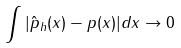Convert formula to latex. <formula><loc_0><loc_0><loc_500><loc_500>\int | \hat { p } _ { h } ( x ) - p ( x ) | d x \rightarrow 0</formula> 